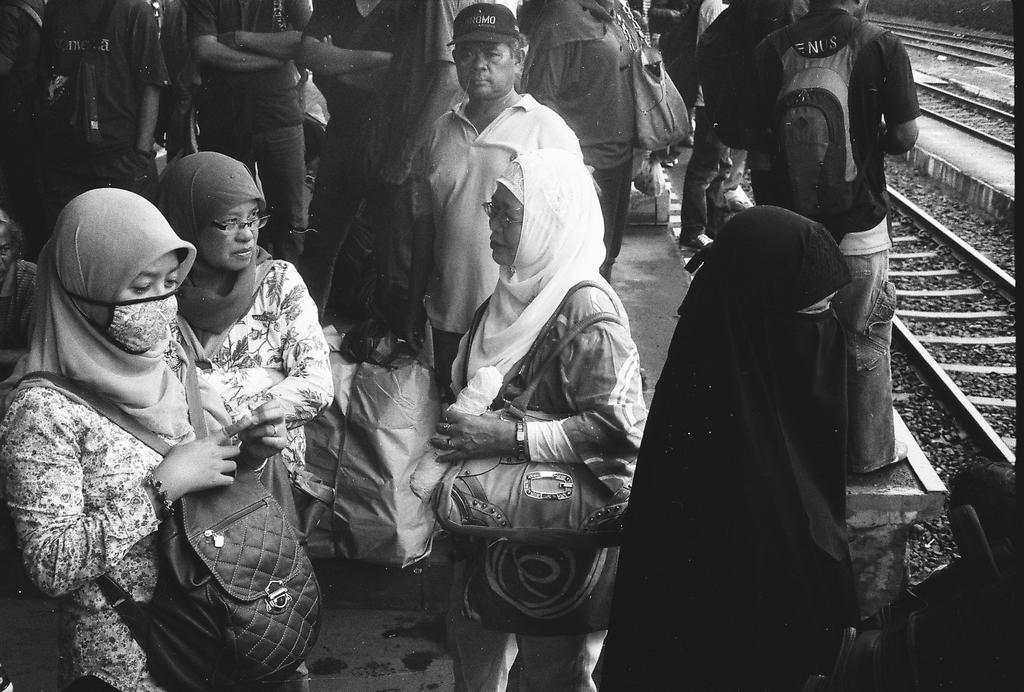Describe this image in one or two sentences. A black and white picture. Most of the persons are standing. These persons wore bags. This is luggage. This is a train track. 